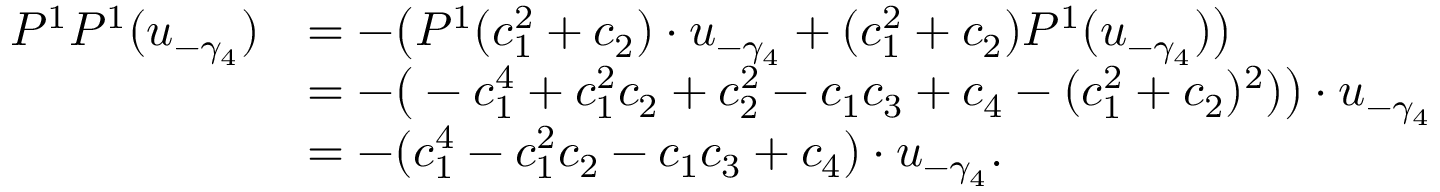<formula> <loc_0><loc_0><loc_500><loc_500>\begin{array} { r l } { P ^ { 1 } P ^ { 1 } ( u _ { - \gamma _ { 4 } } ) } & { = - \left ( P ^ { 1 } ( c _ { 1 } ^ { 2 } + c _ { 2 } ) \cdot u _ { - \gamma _ { 4 } } + ( c _ { 1 } ^ { 2 } + c _ { 2 } ) P ^ { 1 } ( u _ { - \gamma _ { 4 } } ) \right ) } \\ & { = - \left ( - c _ { 1 } ^ { 4 } + c _ { 1 } ^ { 2 } c _ { 2 } + c _ { 2 } ^ { 2 } - c _ { 1 } c _ { 3 } + c _ { 4 } - ( c _ { 1 } ^ { 2 } + c _ { 2 } ) ^ { 2 } ) \right ) \cdot u _ { - \gamma _ { 4 } } } \\ & { = - ( c _ { 1 } ^ { 4 } - c _ { 1 } ^ { 2 } c _ { 2 } - c _ { 1 } c _ { 3 } + c _ { 4 } ) \cdot u _ { - \gamma _ { 4 } } . } \end{array}</formula> 